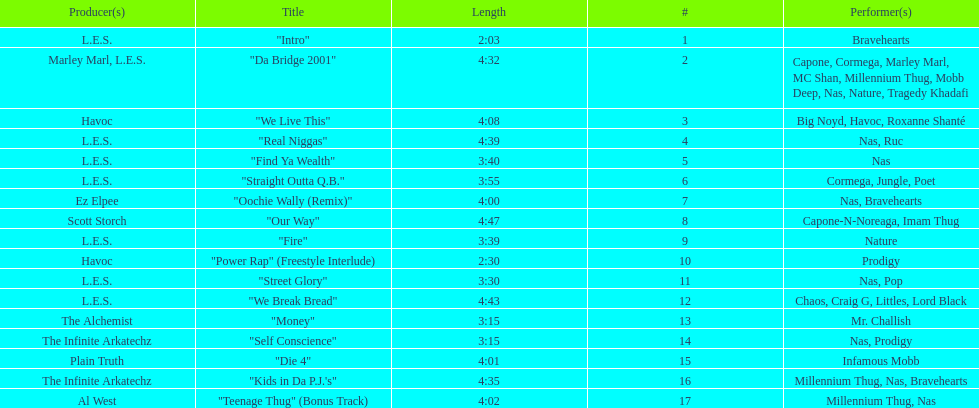How much time does the longest track on the album take? 4:47. 